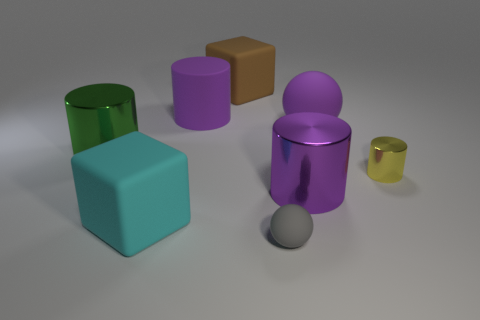Subtract all big purple matte cylinders. How many cylinders are left? 3 Subtract 2 cylinders. How many cylinders are left? 2 Subtract all green cylinders. How many cylinders are left? 3 Add 1 gray objects. How many objects exist? 9 Subtract all cyan cylinders. Subtract all purple balls. How many cylinders are left? 4 Subtract all cubes. How many objects are left? 6 Add 2 small yellow things. How many small yellow things are left? 3 Add 7 large rubber spheres. How many large rubber spheres exist? 8 Subtract 0 cyan spheres. How many objects are left? 8 Subtract all small cyan rubber cylinders. Subtract all gray balls. How many objects are left? 7 